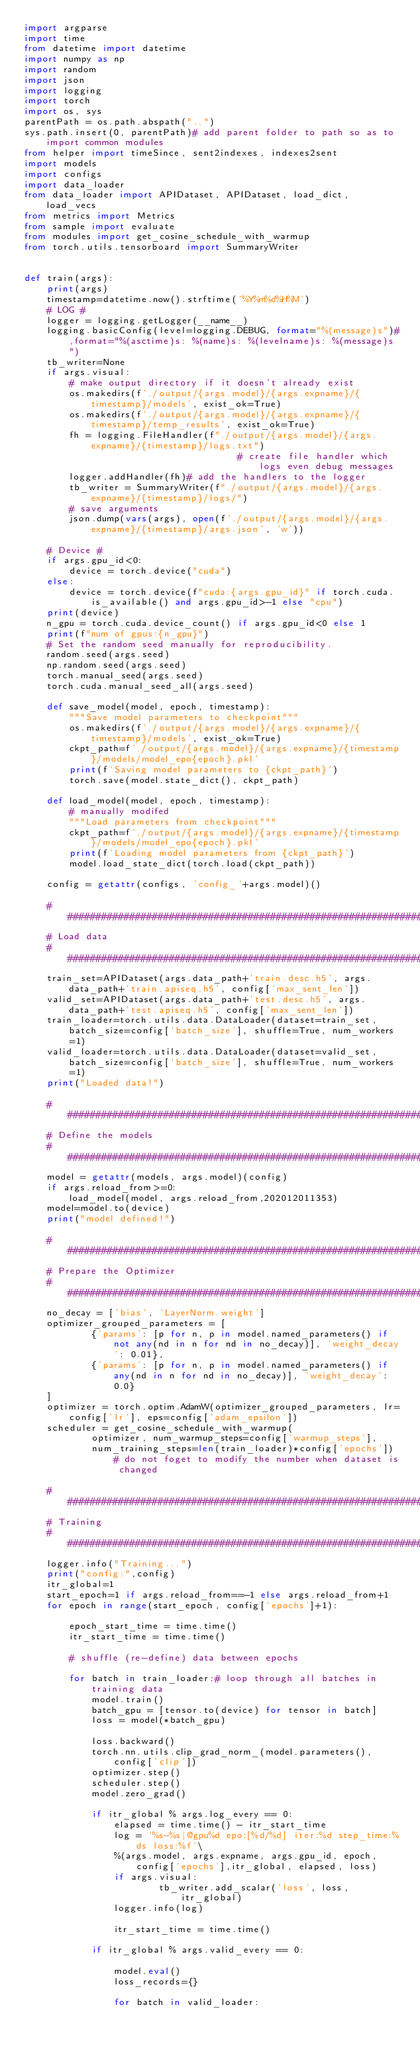Convert code to text. <code><loc_0><loc_0><loc_500><loc_500><_Python_>import argparse
import time
from datetime import datetime
import numpy as np
import random
import json
import logging
import torch
import os, sys
parentPath = os.path.abspath("..")
sys.path.insert(0, parentPath)# add parent folder to path so as to import common modules
from helper import timeSince, sent2indexes, indexes2sent
import models
import configs
import data_loader
from data_loader import APIDataset, APIDataset, load_dict, load_vecs
from metrics import Metrics
from sample import evaluate
from modules import get_cosine_schedule_with_warmup
from torch.utils.tensorboard import SummaryWriter 


def train(args):
    print(args)
    timestamp=datetime.now().strftime('%Y%m%d%H%M')    
    # LOG #
    logger = logging.getLogger(__name__)
    logging.basicConfig(level=logging.DEBUG, format="%(message)s")#,format="%(asctime)s: %(name)s: %(levelname)s: %(message)s")
    tb_writer=None
    if args.visual:
        # make output directory if it doesn't already exist
        os.makedirs(f'./output/{args.model}/{args.expname}/{timestamp}/models', exist_ok=True)
        os.makedirs(f'./output/{args.model}/{args.expname}/{timestamp}/temp_results', exist_ok=True)
        fh = logging.FileHandler(f"./output/{args.model}/{args.expname}/{timestamp}/logs.txt")
                                      # create file handler which logs even debug messages
        logger.addHandler(fh)# add the handlers to the logger
        tb_writer = SummaryWriter(f"./output/{args.model}/{args.expname}/{timestamp}/logs/")
        # save arguments
        json.dump(vars(args), open(f'./output/{args.model}/{args.expname}/{timestamp}/args.json', 'w'))

    # Device #
    if args.gpu_id<0: 
        device = torch.device("cuda")
    else:
        device = torch.device(f"cuda:{args.gpu_id}" if torch.cuda.is_available() and args.gpu_id>-1 else "cpu")
    print(device)
    n_gpu = torch.cuda.device_count() if args.gpu_id<0 else 1
    print(f"num of gpus:{n_gpu}")
    # Set the random seed manually for reproducibility.
    random.seed(args.seed)
    np.random.seed(args.seed)
    torch.manual_seed(args.seed)
    torch.cuda.manual_seed_all(args.seed)

    def save_model(model, epoch, timestamp):
        """Save model parameters to checkpoint"""
        os.makedirs(f'./output/{args.model}/{args.expname}/{timestamp}/models', exist_ok=True)
        ckpt_path=f'./output/{args.model}/{args.expname}/{timestamp}/models/model_epo{epoch}.pkl'
        print(f'Saving model parameters to {ckpt_path}')
        torch.save(model.state_dict(), ckpt_path)

    def load_model(model, epoch, timestamp):
        # manually modifed 
        """Load parameters from checkpoint"""
        ckpt_path=f'./output/{args.model}/{args.expname}/{timestamp}/models/model_epo{epoch}.pkl'
        print(f'Loading model parameters from {ckpt_path}')
        model.load_state_dict(torch.load(ckpt_path))

    config = getattr(configs, 'config_'+args.model)()

    ###############################################################################
    # Load data
    ###############################################################################
    train_set=APIDataset(args.data_path+'train.desc.h5', args.data_path+'train.apiseq.h5', config['max_sent_len'])
    valid_set=APIDataset(args.data_path+'test.desc.h5', args.data_path+'test.apiseq.h5', config['max_sent_len'])
    train_loader=torch.utils.data.DataLoader(dataset=train_set, batch_size=config['batch_size'], shuffle=True, num_workers=1)
    valid_loader=torch.utils.data.DataLoader(dataset=valid_set, batch_size=config['batch_size'], shuffle=True, num_workers=1)
    print("Loaded data!")

    ###############################################################################
    # Define the models
    ###############################################################################
    model = getattr(models, args.model)(config) 
    if args.reload_from>=0:
        load_model(model, args.reload_from,202012011353)
    model=model.to(device)
    print("model defined!")
    
    ###############################################################################
    # Prepare the Optimizer
    ###############################################################################
    no_decay = ['bias', 'LayerNorm.weight']
    optimizer_grouped_parameters = [
            {'params': [p for n, p in model.named_parameters() if not any(nd in n for nd in no_decay)], 'weight_decay': 0.01},
            {'params': [p for n, p in model.named_parameters() if any(nd in n for nd in no_decay)], 'weight_decay': 0.0}
    ]    
    optimizer = torch.optim.AdamW(optimizer_grouped_parameters, lr=config['lr'], eps=config['adam_epsilon'])        
    scheduler = get_cosine_schedule_with_warmup(
            optimizer, num_warmup_steps=config['warmup_steps'], 
            num_training_steps=len(train_loader)*config['epochs']) # do not foget to modify the number when dataset is changed

    ###############################################################################
    # Training
    ###############################################################################
    logger.info("Training...")
    print("config:",config)
    itr_global=1
    start_epoch=1 if args.reload_from==-1 else args.reload_from+1
    for epoch in range(start_epoch, config['epochs']+1):

        epoch_start_time = time.time()
        itr_start_time = time.time()

        # shuffle (re-define) data between epochs   

        for batch in train_loader:# loop through all batches in training data
            model.train()
            batch_gpu = [tensor.to(device) for tensor in batch]
            loss = model(*batch_gpu)  
            
            loss.backward()
            torch.nn.utils.clip_grad_norm_(model.parameters(), config['clip'])
            optimizer.step()
            scheduler.step()
            model.zero_grad()

            if itr_global % args.log_every == 0:
                elapsed = time.time() - itr_start_time
                log = '%s-%s|@gpu%d epo:[%d/%d] iter:%d step_time:%ds loss:%f'\
                %(args.model, args.expname, args.gpu_id, epoch, config['epochs'],itr_global, elapsed, loss)
                if args.visual:
                        tb_writer.add_scalar('loss', loss, itr_global)
                logger.info(log)

                itr_start_time = time.time()   

            if itr_global % args.valid_every == 0:
             
                model.eval()
                loss_records={}

                for batch in valid_loader:</code> 